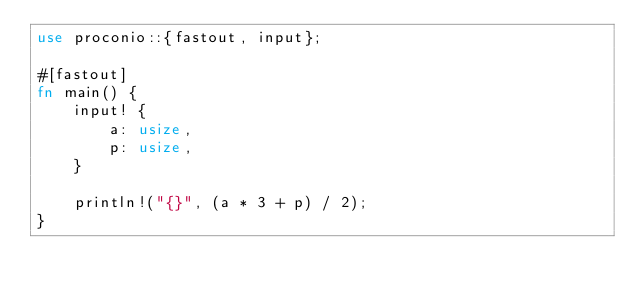Convert code to text. <code><loc_0><loc_0><loc_500><loc_500><_Rust_>use proconio::{fastout, input};

#[fastout]
fn main() {
    input! {
        a: usize,
        p: usize,
    }

    println!("{}", (a * 3 + p) / 2);
}</code> 